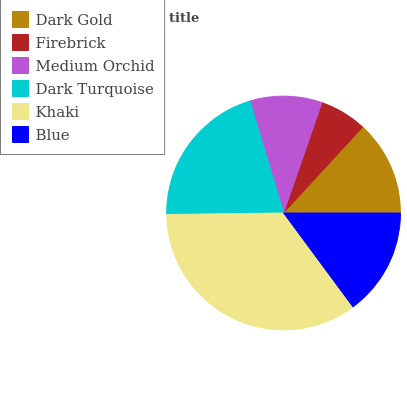Is Firebrick the minimum?
Answer yes or no. Yes. Is Khaki the maximum?
Answer yes or no. Yes. Is Medium Orchid the minimum?
Answer yes or no. No. Is Medium Orchid the maximum?
Answer yes or no. No. Is Medium Orchid greater than Firebrick?
Answer yes or no. Yes. Is Firebrick less than Medium Orchid?
Answer yes or no. Yes. Is Firebrick greater than Medium Orchid?
Answer yes or no. No. Is Medium Orchid less than Firebrick?
Answer yes or no. No. Is Blue the high median?
Answer yes or no. Yes. Is Dark Gold the low median?
Answer yes or no. Yes. Is Khaki the high median?
Answer yes or no. No. Is Medium Orchid the low median?
Answer yes or no. No. 